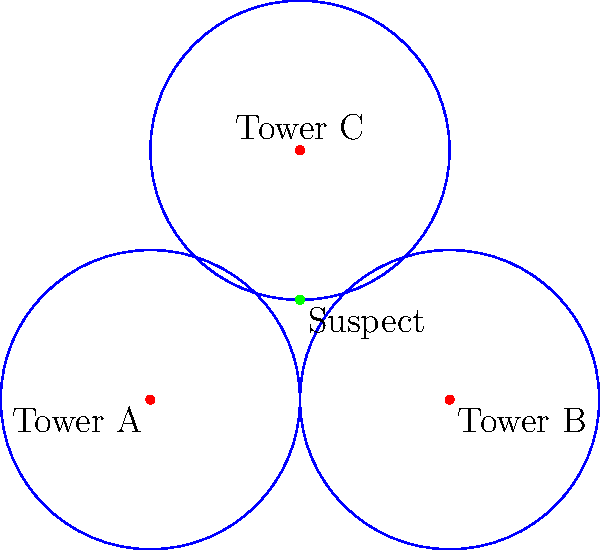Given the cell tower locations and signal ranges shown in the map above, what is the most likely location of the suspect based on the triangulation of cell tower pings? Provide the coordinates (x, y) of the suspect's estimated position. To determine the suspect's location using cell tower triangulation, we follow these steps:

1. Identify the cell towers: We have three towers A (0,0), B (6,0), and C (3,5).

2. Analyze the signal ranges: Each tower has a circular signal range with a radius of 3 units.

3. Find the intersection point: The suspect's location is where all three signal ranges intersect.

4. Determine the coordinates: By visually inspecting the intersection point of the three circles, we can estimate the suspect's location.

5. Verify the solution: The point (3,2) appears to be at the center of the area where all three circles overlap.

6. Consider real-world factors: In practice, factors like terrain, buildings, and signal interference would affect accuracy. This simplified model assumes ideal conditions.

7. Conclude: Based on the given information and the graphical representation, the most likely location of the suspect is at coordinates (3,2).
Answer: (3,2) 